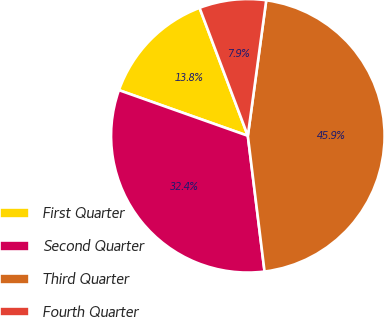<chart> <loc_0><loc_0><loc_500><loc_500><pie_chart><fcel>First Quarter<fcel>Second Quarter<fcel>Third Quarter<fcel>Fourth Quarter<nl><fcel>13.84%<fcel>32.37%<fcel>45.9%<fcel>7.89%<nl></chart> 